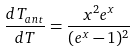Convert formula to latex. <formula><loc_0><loc_0><loc_500><loc_500>\frac { d T _ { a n t } } { d T } = \frac { x ^ { 2 } e ^ { x } } { ( e ^ { x } - 1 ) ^ { 2 } }</formula> 